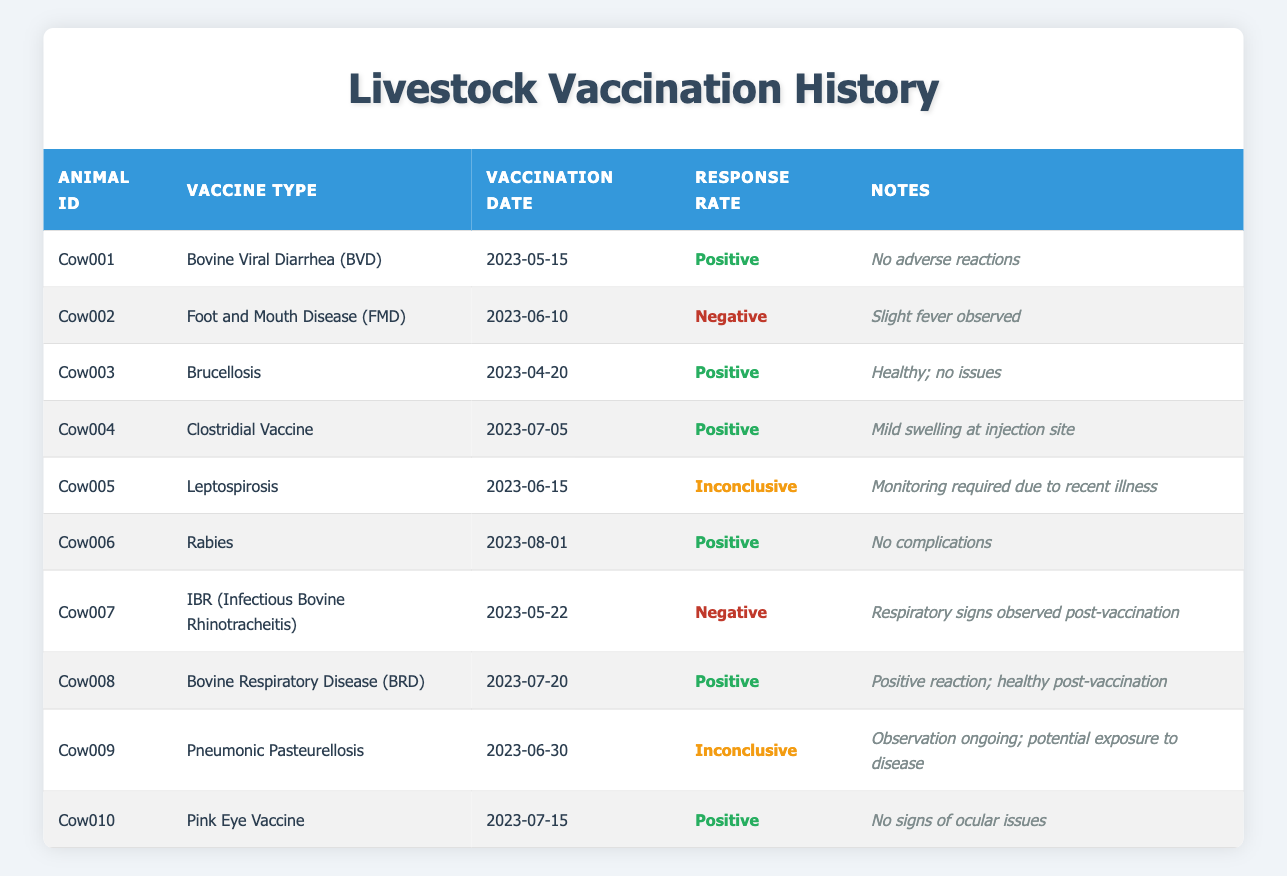What is the vaccination date for Cow001? The table lists the vaccination date for each cow under the "Vaccination Date" column. For Cow001, that date is 2023-05-15.
Answer: 2023-05-15 How many cows had a positive response to vaccination? By counting the entries in the "Response Rate" column, I see that Cow001, Cow003, Cow004, Cow006, Cow008, and Cow010 have a "Positive" response. This totals six cows.
Answer: 6 Which vaccine was administered to Cow007? The "Vaccine Type" column indicates the specific vaccine given to each cow. Cow007 received the IBR (Infectious Bovine Rhinotracheitis) vaccine.
Answer: IBR (Infectious Bovine Rhinotracheitis) Was there any adverse reaction noted for Cow006? Reviewing the notes under the "Notes" column for Cow006, it states "No complications," indicating there were no adverse reactions observed.
Answer: Yes What is the percentage of cows with inconclusive responses? There are two cows (Cow005 and Cow009) with an "Inconclusive" response out of a total of ten cows. Calculating the percentage: (2/10) * 100 = 20%.
Answer: 20% Which cow had a reaction of mild swelling at the injection site? In the "Notes" column, Cow004 is noted to have "Mild swelling at injection site."
Answer: Cow004 Did any cows exhibit respiratory signs post-vaccination? Looking at the notes in the table, Cow007 experienced "Respiratory signs observed post-vaccination." Therefore, yes, at least one cow exhibited these signs.
Answer: Yes What was the most recent vaccination date among the cows in the table? The most recent date listed in the "Vaccination Date" column is for Cow006, which is 2023-08-01.
Answer: 2023-08-01 How many cows received the Leptospirosis vaccine? By checking the "Vaccine Type" column, only Cow005 is listed as having received the Leptospirosis vaccine, so the count is one.
Answer: 1 